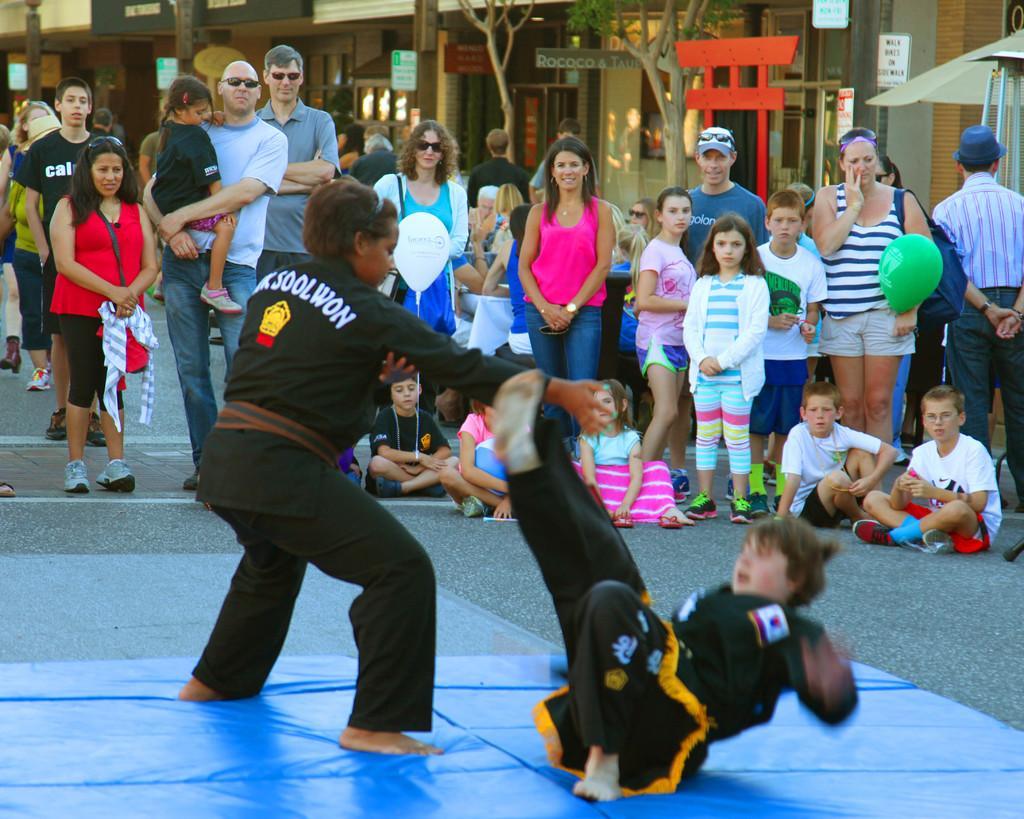Please provide a concise description of this image. In this picture we can see two people on a blue sheet. There are a few people sitting on the path. We can see some signboards and other boards on the poles. There is an umbrella and a stand on the right side. We can see a few trees and buildings in the background. 